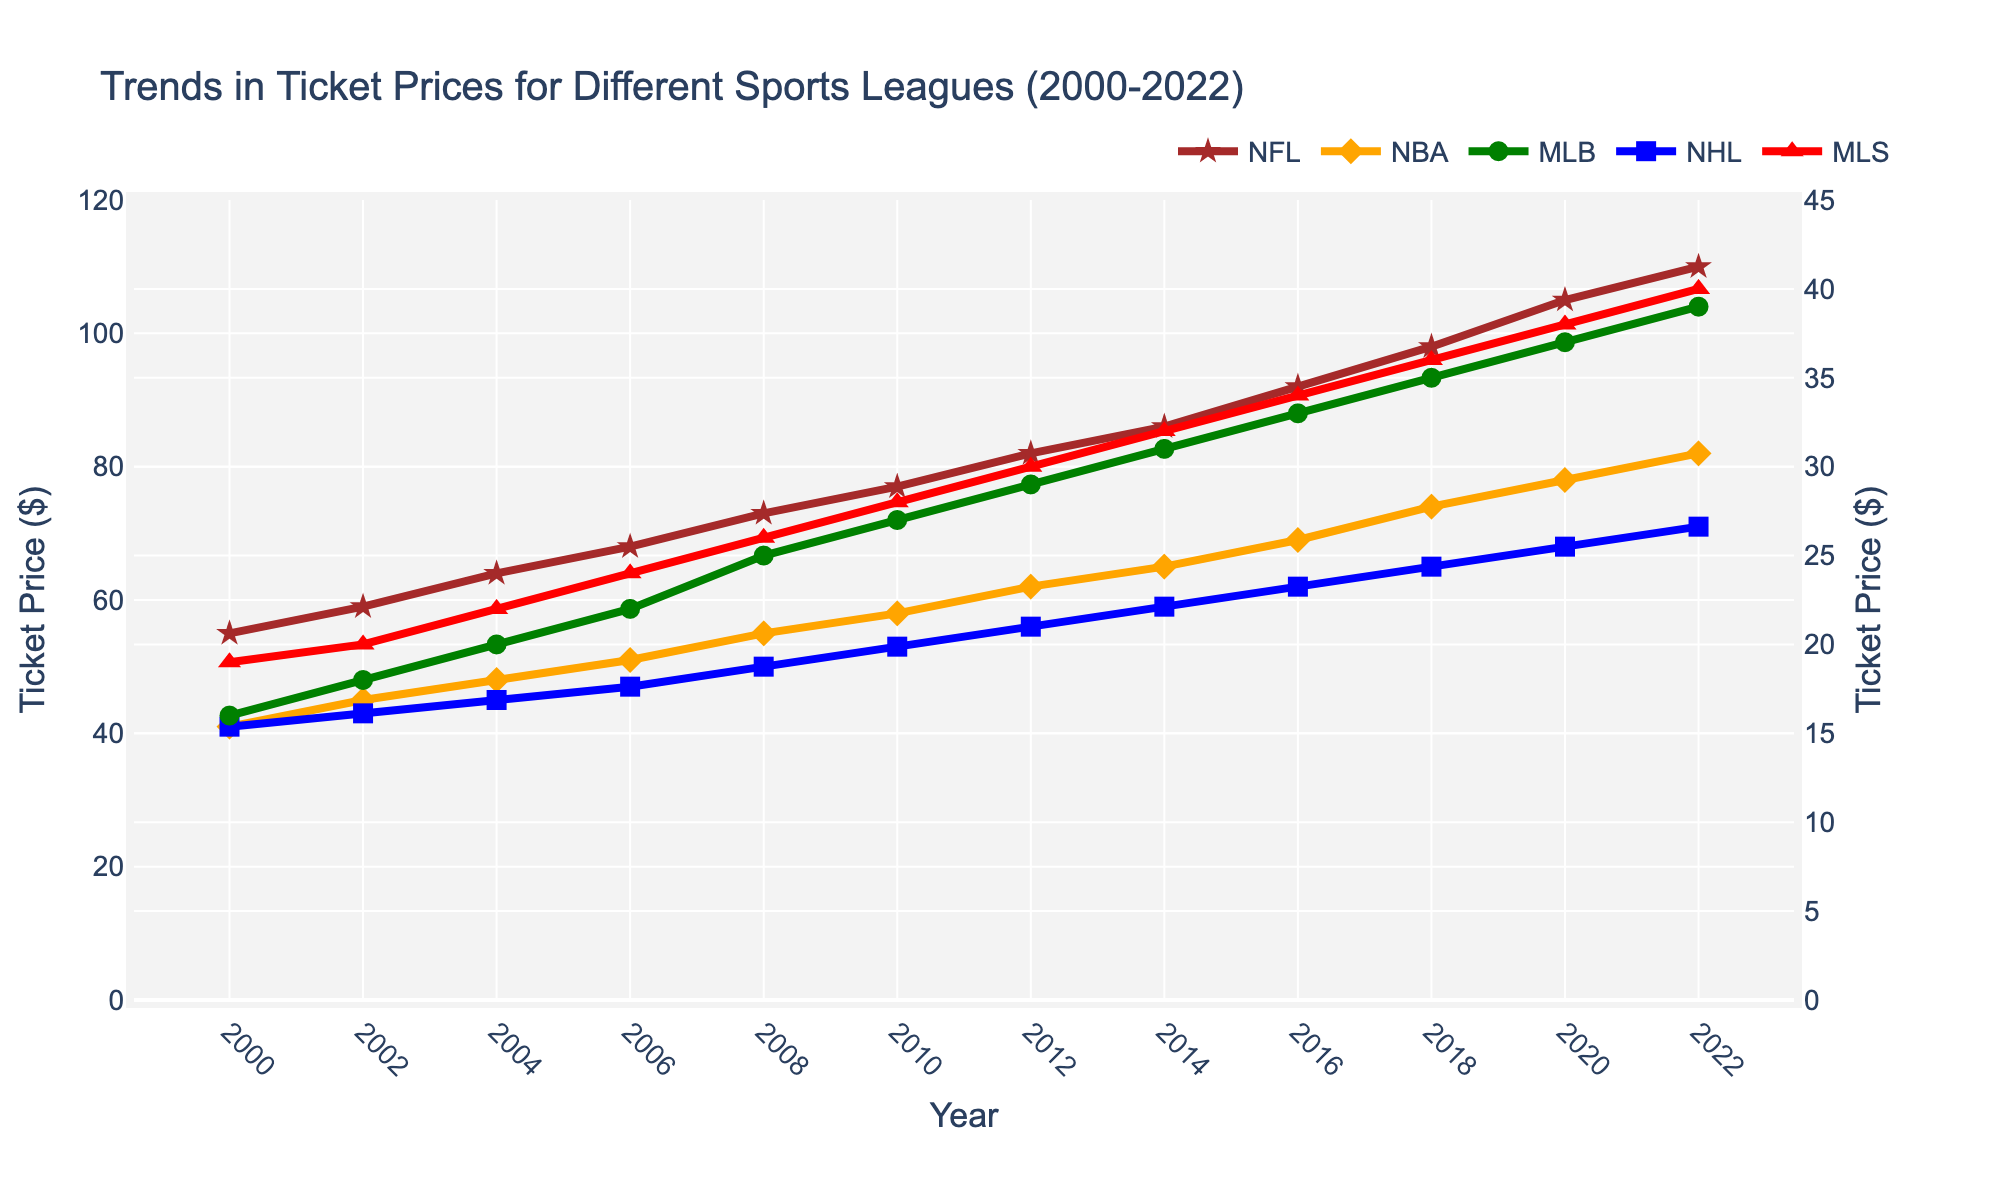what are the highest and lowest ticket prices for MLB from 2000 to 2022? To find the highest and lowest ticket prices for MLB, look at the MLB line on the graph. The highest point is in 2022 at $39, and the lowest point is in 2000 at $16.
Answer: Highest: $39, Lowest: $16 Did NHL ticket prices ever exceed NFL ticket prices between 2000 and 2022? Compare the NHL and NFL lines on the graph. The NHL line never crosses above the NFL line at any point between 2000 and 2022.
Answer: No Which sport had the steepest increase in ticket prices from 2000 to 2022? The sport with the steepest increase would be the one with the highest slope on its line. The NFL line shows the largest increase from $55 in 2000 to $110 in 2022, doubling the price.
Answer: NFL In which year did MLS ticket prices surpass $30? Look at the MLS line and find when it first crosses the $30 mark on the y-axis. This happens in 2012.
Answer: 2012 How much did NBA ticket prices increase from 2000 to 2018? The NBA ticket prices in 2000 were $41, and in 2018 they were $74. The increase is $74 - $41 = $33.
Answer: $33 Compare the ticket prices of MLS and MLB in 2022. Which one is higher and by how much? In 2022, MLS ticket prices are $40, and MLB ticket prices are $39. MLS is higher by $40 - $39 = $1.
Answer: MLS, $1 Between 2004 and 2008, which sport had the slowest growth in ticket prices? Observe the slopes of the lines for each sport between 2004 and 2008. The MLB line has the smallest increase, going from $20 to $25, an increase of $5.
Answer: MLB What’s the average ticket price across all sports in 2006? The ticket prices in 2006 are NFL $68, NBA $51, MLB $22, NHL $47, and MLS $24. The average is ($68 + $51 + $22 + $47 + $24) / 5 = $42.4.
Answer: $42.4 What's the difference in ticket prices between the sport with the highest and lowest prices in the year 2010? In 2010, the ticket prices are NFL $77, NBA $58, MLB $27, NHL $53, and MLS $28. The highest is NFL $77 and the lowest is MLB $27, so the difference is $77 - $27 = $50.
Answer: $50 